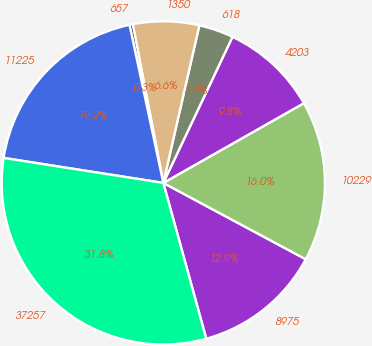<chart> <loc_0><loc_0><loc_500><loc_500><pie_chart><fcel>8975<fcel>10229<fcel>4203<fcel>618<fcel>1350<fcel>657<fcel>11225<fcel>37257<nl><fcel>12.89%<fcel>16.04%<fcel>9.75%<fcel>3.46%<fcel>6.61%<fcel>0.32%<fcel>19.18%<fcel>31.75%<nl></chart> 